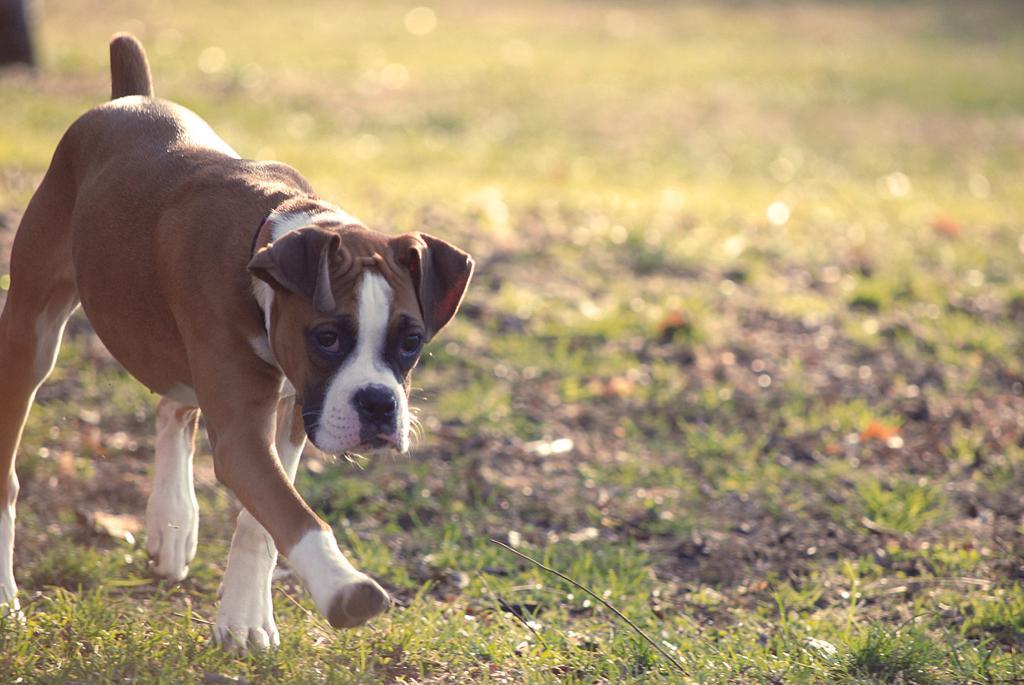Describe this image in one or two sentences. In this picture we can see a dog is walking on the grass. Behind the dog there is the blurred background. 